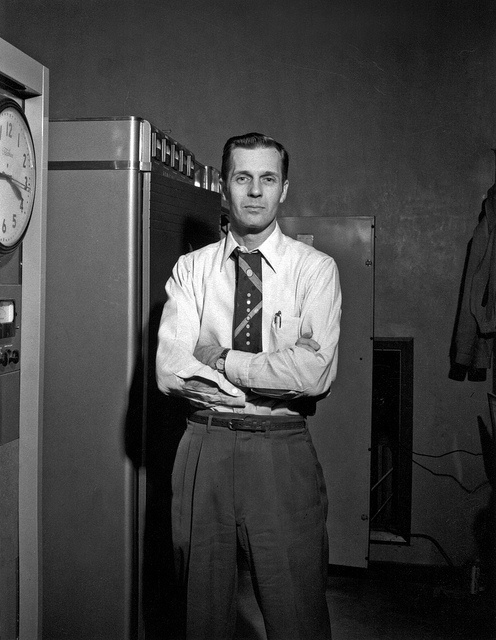Describe the objects in this image and their specific colors. I can see people in black, lightgray, darkgray, and gray tones, clock in black, darkgray, gray, and lightgray tones, tie in black, gray, darkgray, and lightgray tones, and clock in black, darkgray, gray, and lightgray tones in this image. 